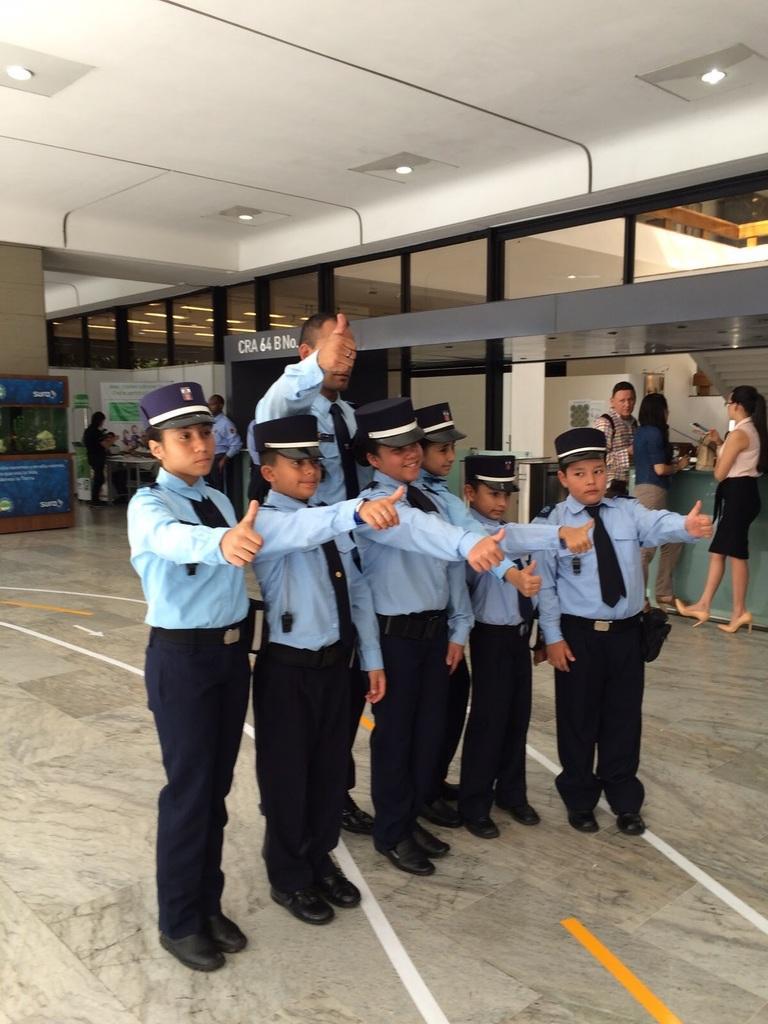Could you give a brief overview of what you see in this image? In this picture, we can see a few people and a few are in a dress code, we can see the floor, stores, some text on the board, we can see banners, wall, and roof with lights. 